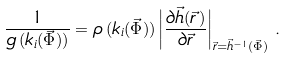<formula> <loc_0><loc_0><loc_500><loc_500>\frac { 1 } { g \left ( k _ { i } ( \vec { \Phi } ) \right ) } = \rho \left ( k _ { i } ( \vec { \Phi } ) \right ) \left | \frac { \partial \vec { h } ( \vec { r \, } ) } { \partial \vec { r } } \right | _ { \vec { r } = \vec { h } ^ { - 1 } ( \vec { \Phi } ) } \, .</formula> 